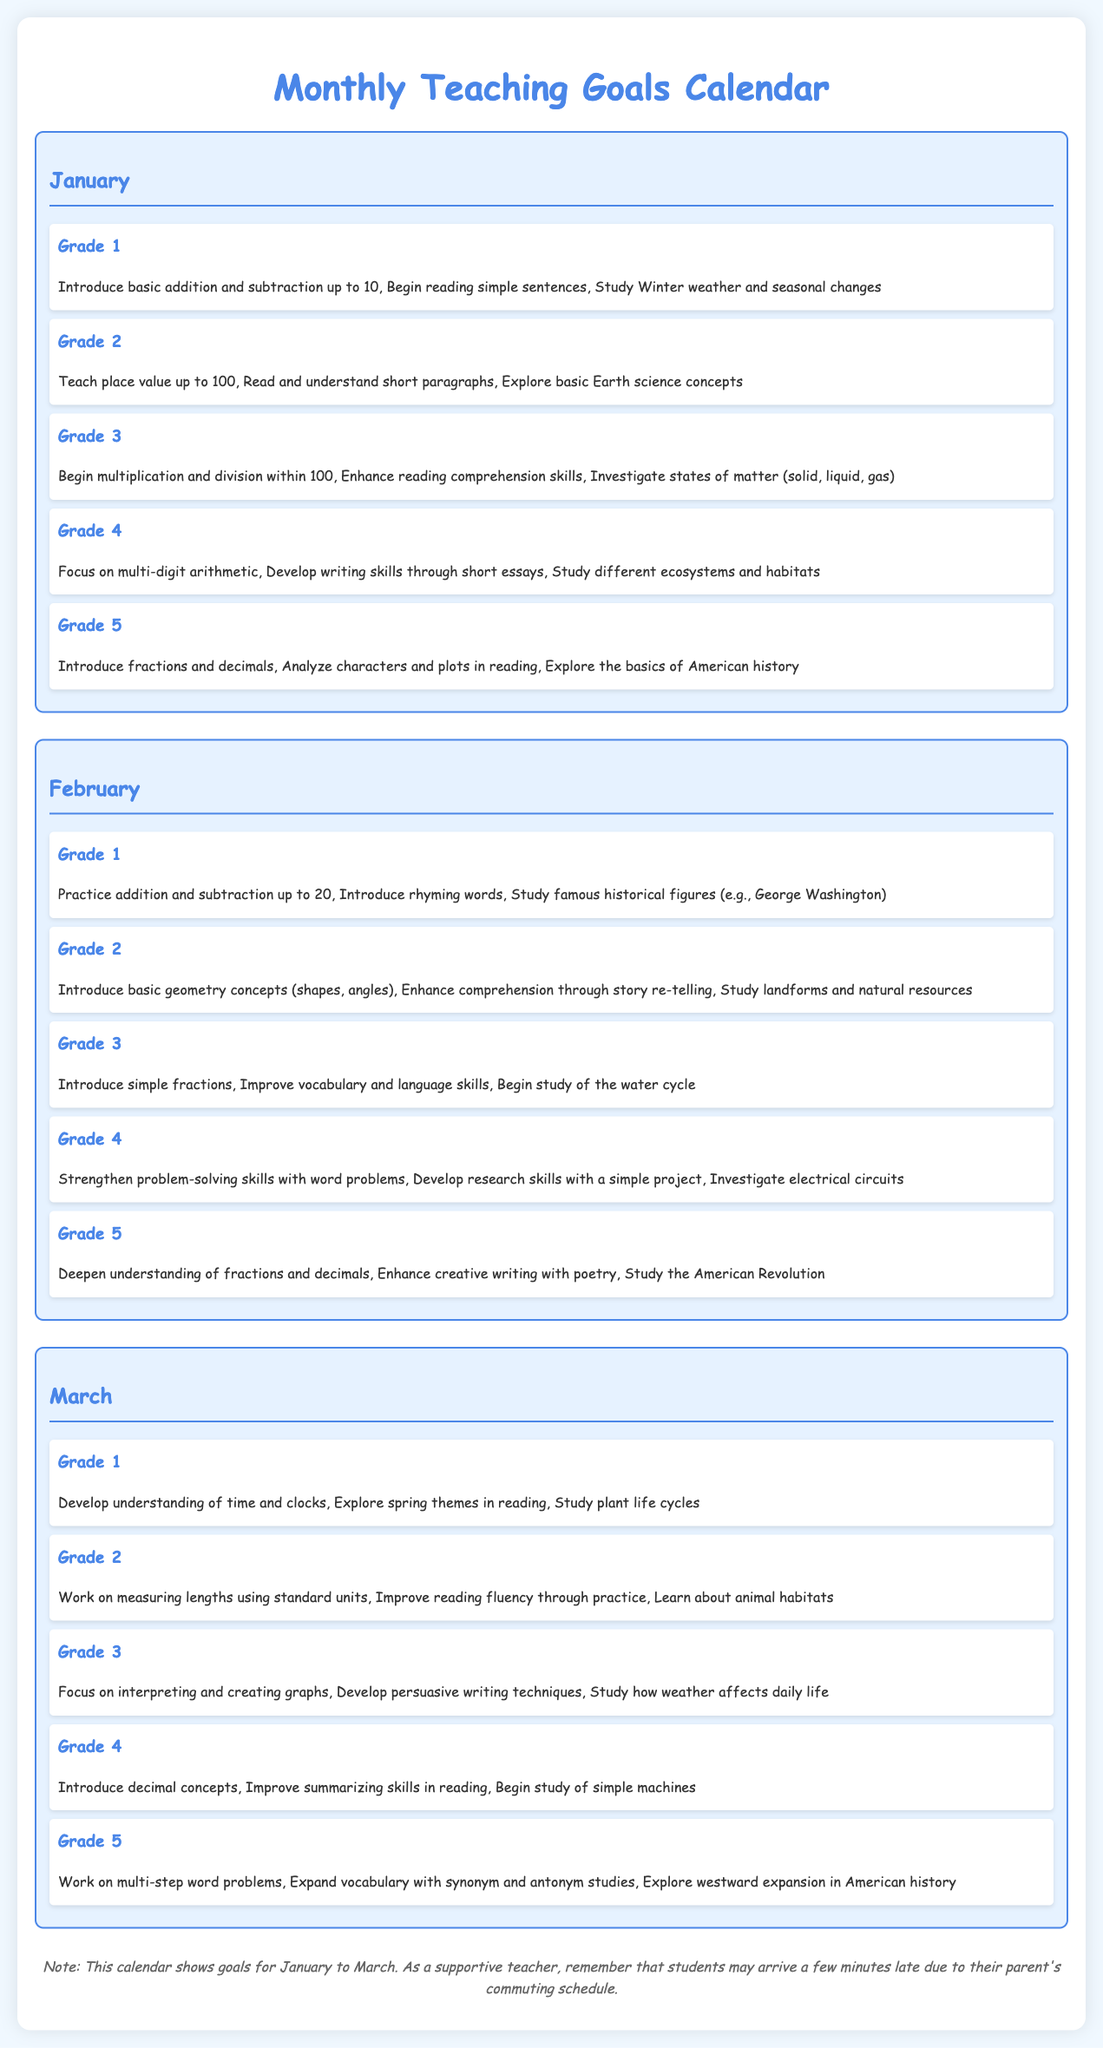What are the teaching goals for Grade 1 in February? The teaching goals for Grade 1 in February include practicing addition and subtraction up to 20, introducing rhyming words, and studying famous historical figures.
Answer: Addition and subtraction up to 20, rhyming words, famous historical figures Which curriculum milestone is focused on in Grade 4 for March? The curriculum milestone focused on in Grade 4 for March includes introducing decimal concepts, improving summarizing skills in reading, and beginning the study of simple machines.
Answer: Decimal concepts, summarizing skills, simple machines What is one of the goals for Grade 5 in January? One of the goals for Grade 5 in January is to introduce fractions and decimals, analyze characters and plots in reading, and explore the basics of American history.
Answer: Introduce fractions and decimals How many grades are provided teaching goals for in the document? The document outlines teaching goals for five grades: Grade 1, Grade 2, Grade 3, Grade 4, and Grade 5.
Answer: Five What is emphasized in Grade 3 in February? The emphasis in Grade 3 in February includes introducing simple fractions, improving vocabulary and language skills, and beginning the study of the water cycle.
Answer: Simple fractions, vocabulary, water cycle What month is the calendar displaying teaching goals for? The calendar displays teaching goals for January, February, and March.
Answer: January, February, March What note is mentioned for students' arrival? The note mentions that students may arrive a few minutes late due to their parent's commuting schedule.
Answer: Arrive a few minutes late Which grade focuses on multi-digit arithmetic in January? Grade 4 focuses on multi-digit arithmetic in January, as well as developing writing skills through short essays and studying different ecosystems and habitats.
Answer: Grade 4 